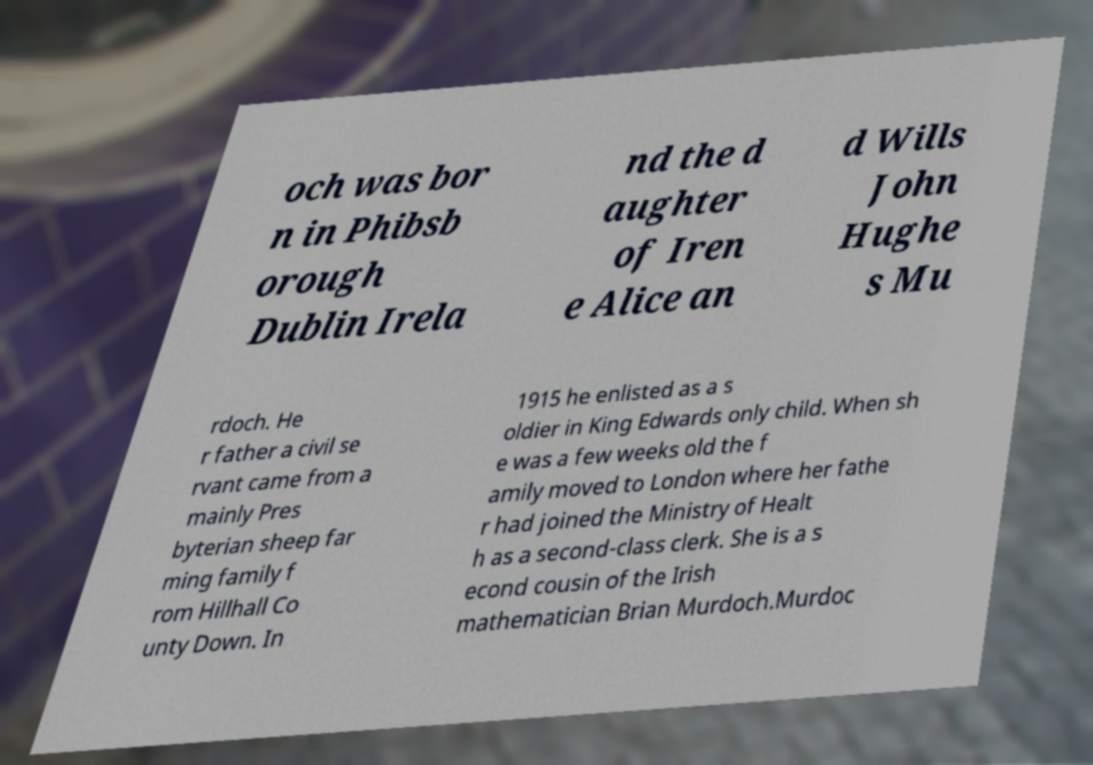Can you read and provide the text displayed in the image?This photo seems to have some interesting text. Can you extract and type it out for me? och was bor n in Phibsb orough Dublin Irela nd the d aughter of Iren e Alice an d Wills John Hughe s Mu rdoch. He r father a civil se rvant came from a mainly Pres byterian sheep far ming family f rom Hillhall Co unty Down. In 1915 he enlisted as a s oldier in King Edwards only child. When sh e was a few weeks old the f amily moved to London where her fathe r had joined the Ministry of Healt h as a second-class clerk. She is a s econd cousin of the Irish mathematician Brian Murdoch.Murdoc 